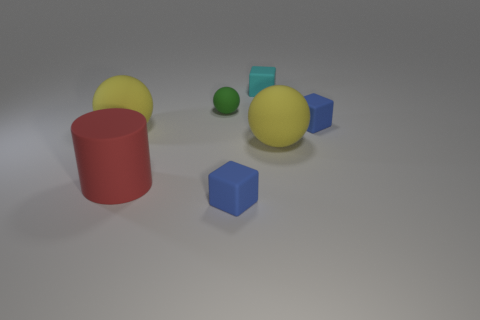What shape is the cyan thing that is the same size as the green object?
Your response must be concise. Cube. There is a big yellow matte sphere that is in front of the yellow object that is left of the green rubber object; how many small green rubber things are behind it?
Give a very brief answer. 1. Are there more yellow matte spheres in front of the large red rubber cylinder than blue matte cubes in front of the tiny matte sphere?
Give a very brief answer. No. What number of other matte things are the same shape as the small green rubber thing?
Offer a terse response. 2. How many things are either small blue matte blocks that are in front of the red matte object or yellow things that are right of the small green matte sphere?
Your answer should be very brief. 2. What is the material of the yellow thing behind the big object to the right of the small blue rubber block in front of the big red object?
Offer a very short reply. Rubber. The cube that is behind the big red rubber cylinder and in front of the cyan matte thing is made of what material?
Make the answer very short. Rubber. Are there any cyan shiny cylinders of the same size as the red object?
Make the answer very short. No. What number of yellow matte spheres are there?
Give a very brief answer. 2. There is a small cyan rubber block; how many large matte balls are on the right side of it?
Keep it short and to the point. 1. 